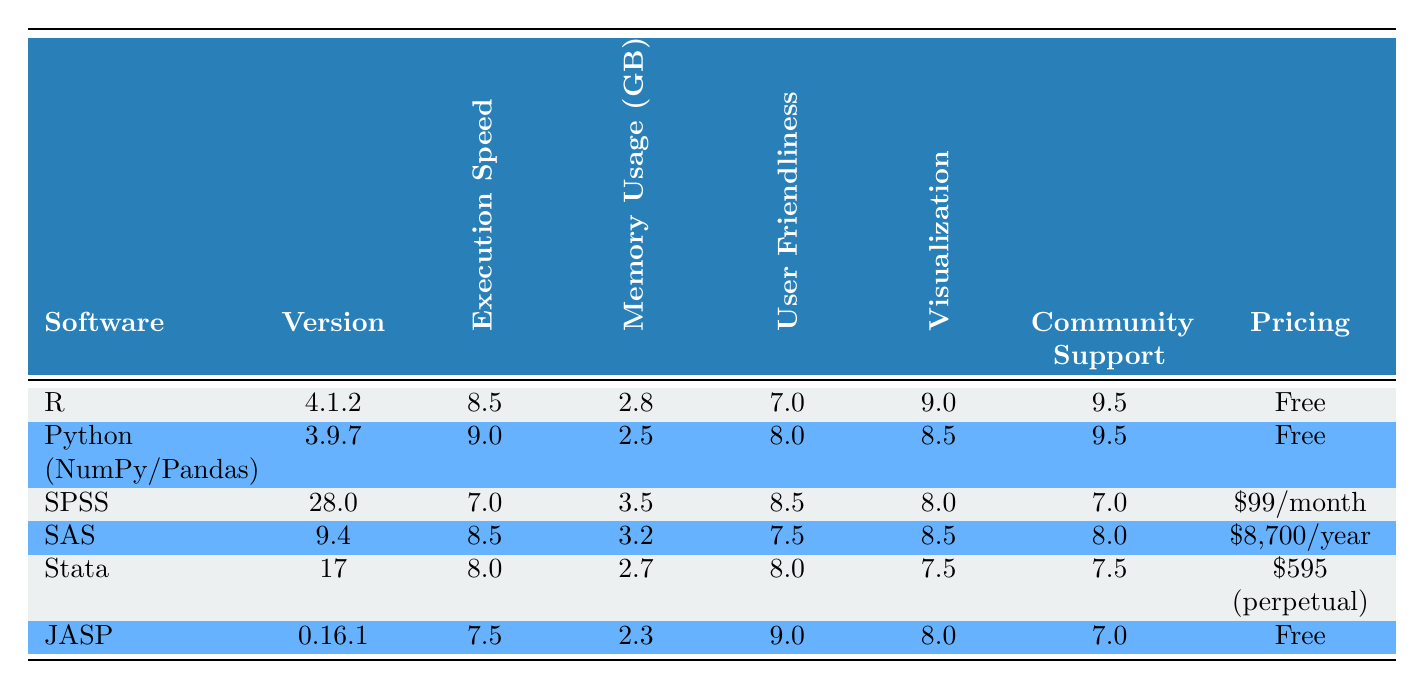What is the execution speed of SPSS? The execution speed of SPSS is listed directly in the table under the "Execution Speed" column next to SPSS’s name. It shows a value of 7.0 seconds for processing 1 million rows.
Answer: 7.0 Which software has the lowest memory usage? By comparing the "Memory Usage" values across all software packages, JASP has the lowest memory usage at 2.3 GB for processing 1 million rows.
Answer: 2.3 Is Python (with NumPy/Pandas) more user-friendly than SAS? In the "User Friendliness" column, Python has a rating of 8.0, while SAS has a rating of 7.5. Since 8.0 is greater than 7.5, Python is indeed more user-friendly than SAS.
Answer: Yes What is the average execution speed of R and Stata combined? To find the average execution speed of R and Stata, we first retrieve their speeds: R = 8.5 and Stata = 8.0. Then we sum these speeds: 8.5 + 8.0 = 16.5, and divide by 2 to find the average: 16.5 / 2 = 8.25.
Answer: 8.25 Does JASP have the highest community support rating? Looking at the "Community Support" ratings for each software, JASP has a rating of 7.0. Comparing it with others: R and Python both have 9.5, which are higher than JASP. Thus, JASP does not have the highest rating.
Answer: No Which software package has the easiest learning curve? Referring to the "Learning Curve" column, SPSS has the easiest learning curve described as "Easy," while JASP has a "Very Easy" rating. Therefore, JASP is the easiest.
Answer: JASP Which software has better visualization capabilities, SAS or SPSS? The table lists SAS’s visualization capabilities as 8.5 and SPSS’s as 8.0. Comparing these values, SAS (8.5) has better visualization capabilities than SPSS (8.0).
Answer: SAS What is the difference in execution speed between Python (with NumPy/Pandas) and JASP? Python has an execution speed of 9.0, while JASP has 7.5. The difference is calculated as 9.0 - 7.5 = 1.5. Thus, Python is faster by 1.5 seconds.
Answer: 1.5 How many software packages are available for free? By counting in the "Pricing" column, R, Python, and JASP are listed as free, making a total of three free software packages available.
Answer: 3 